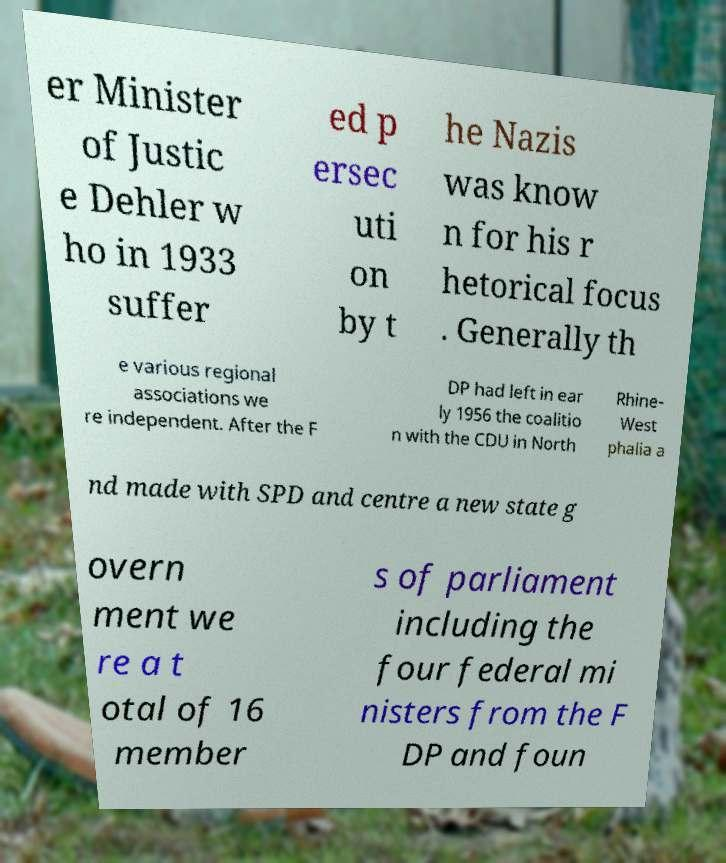I need the written content from this picture converted into text. Can you do that? er Minister of Justic e Dehler w ho in 1933 suffer ed p ersec uti on by t he Nazis was know n for his r hetorical focus . Generally th e various regional associations we re independent. After the F DP had left in ear ly 1956 the coalitio n with the CDU in North Rhine- West phalia a nd made with SPD and centre a new state g overn ment we re a t otal of 16 member s of parliament including the four federal mi nisters from the F DP and foun 